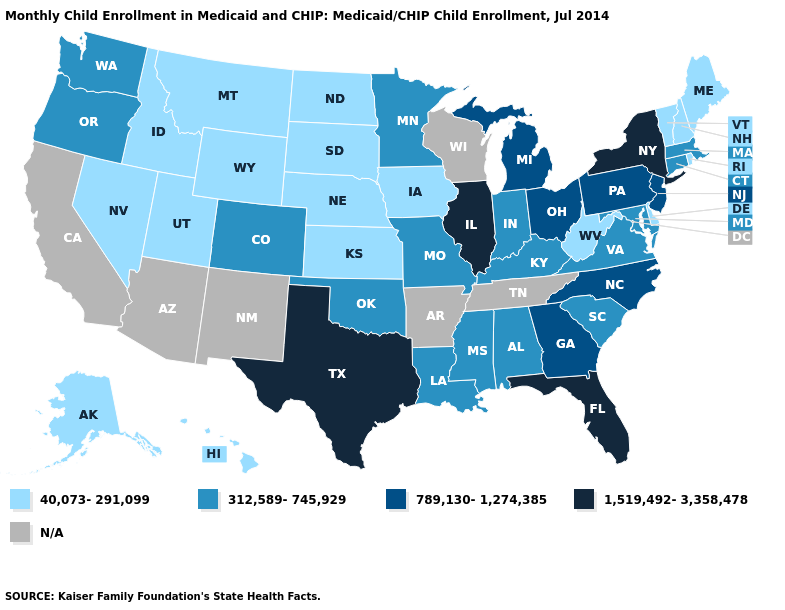Among the states that border Maryland , which have the lowest value?
Quick response, please. Delaware, West Virginia. What is the value of Kentucky?
Be succinct. 312,589-745,929. Name the states that have a value in the range 1,519,492-3,358,478?
Keep it brief. Florida, Illinois, New York, Texas. Among the states that border Georgia , does Florida have the highest value?
Concise answer only. Yes. Which states have the lowest value in the South?
Keep it brief. Delaware, West Virginia. What is the value of Hawaii?
Concise answer only. 40,073-291,099. Name the states that have a value in the range 40,073-291,099?
Short answer required. Alaska, Delaware, Hawaii, Idaho, Iowa, Kansas, Maine, Montana, Nebraska, Nevada, New Hampshire, North Dakota, Rhode Island, South Dakota, Utah, Vermont, West Virginia, Wyoming. What is the value of South Carolina?
Concise answer only. 312,589-745,929. What is the value of Texas?
Answer briefly. 1,519,492-3,358,478. What is the value of Wyoming?
Quick response, please. 40,073-291,099. Among the states that border New Hampshire , does Vermont have the highest value?
Quick response, please. No. Does the map have missing data?
Be succinct. Yes. What is the value of Texas?
Keep it brief. 1,519,492-3,358,478. 